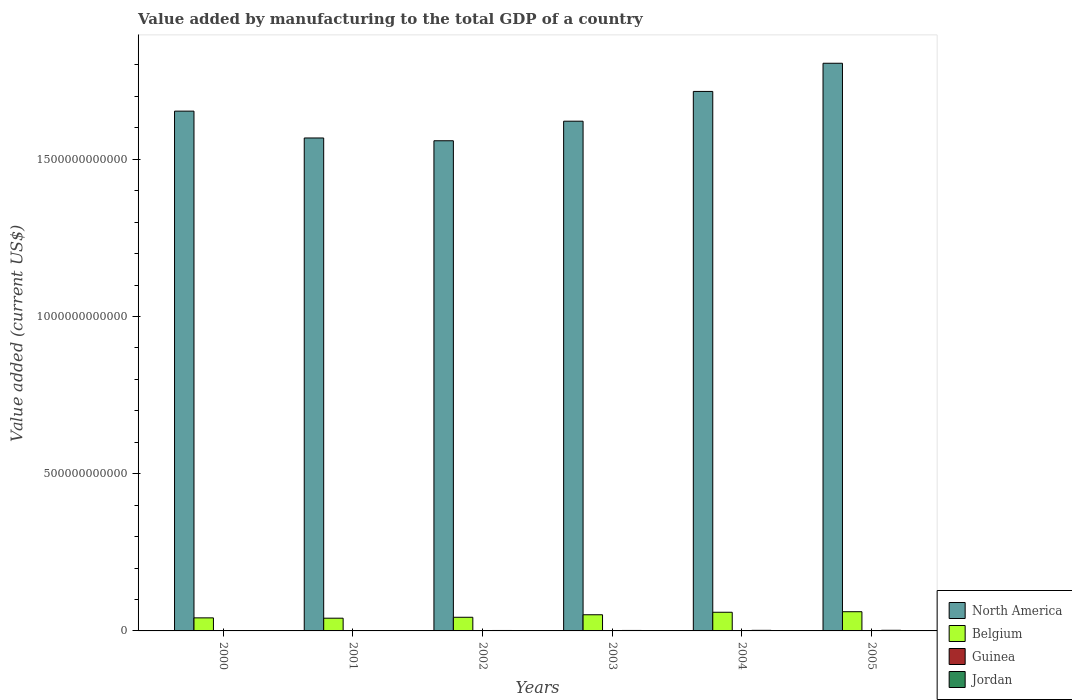How many different coloured bars are there?
Provide a short and direct response. 4. Are the number of bars on each tick of the X-axis equal?
Offer a terse response. Yes. How many bars are there on the 1st tick from the left?
Your response must be concise. 4. How many bars are there on the 2nd tick from the right?
Your answer should be compact. 4. What is the value added by manufacturing to the total GDP in Belgium in 2004?
Offer a terse response. 5.93e+1. Across all years, what is the maximum value added by manufacturing to the total GDP in Jordan?
Your answer should be compact. 2.01e+09. Across all years, what is the minimum value added by manufacturing to the total GDP in North America?
Provide a succinct answer. 1.56e+12. In which year was the value added by manufacturing to the total GDP in Guinea minimum?
Make the answer very short. 2001. What is the total value added by manufacturing to the total GDP in Belgium in the graph?
Make the answer very short. 2.97e+11. What is the difference between the value added by manufacturing to the total GDP in Jordan in 2001 and that in 2005?
Ensure brevity in your answer.  -7.97e+08. What is the difference between the value added by manufacturing to the total GDP in Jordan in 2000 and the value added by manufacturing to the total GDP in North America in 2003?
Offer a terse response. -1.62e+12. What is the average value added by manufacturing to the total GDP in Belgium per year?
Keep it short and to the point. 4.95e+1. In the year 2000, what is the difference between the value added by manufacturing to the total GDP in Belgium and value added by manufacturing to the total GDP in Guinea?
Your answer should be very brief. 4.14e+1. In how many years, is the value added by manufacturing to the total GDP in Belgium greater than 1200000000000 US$?
Provide a short and direct response. 0. What is the ratio of the value added by manufacturing to the total GDP in North America in 2002 to that in 2003?
Offer a very short reply. 0.96. Is the value added by manufacturing to the total GDP in North America in 2003 less than that in 2005?
Your answer should be very brief. Yes. What is the difference between the highest and the second highest value added by manufacturing to the total GDP in Guinea?
Ensure brevity in your answer.  3.41e+06. What is the difference between the highest and the lowest value added by manufacturing to the total GDP in Belgium?
Your answer should be very brief. 2.06e+1. What does the 2nd bar from the left in 2003 represents?
Offer a very short reply. Belgium. Are all the bars in the graph horizontal?
Make the answer very short. No. How many years are there in the graph?
Offer a very short reply. 6. What is the difference between two consecutive major ticks on the Y-axis?
Offer a terse response. 5.00e+11. Does the graph contain any zero values?
Keep it short and to the point. No. How many legend labels are there?
Offer a terse response. 4. How are the legend labels stacked?
Make the answer very short. Vertical. What is the title of the graph?
Give a very brief answer. Value added by manufacturing to the total GDP of a country. What is the label or title of the Y-axis?
Ensure brevity in your answer.  Value added (current US$). What is the Value added (current US$) of North America in 2000?
Give a very brief answer. 1.65e+12. What is the Value added (current US$) of Belgium in 2000?
Your answer should be compact. 4.15e+1. What is the Value added (current US$) in Guinea in 2000?
Ensure brevity in your answer.  1.13e+08. What is the Value added (current US$) of Jordan in 2000?
Your answer should be compact. 1.14e+09. What is the Value added (current US$) in North America in 2001?
Ensure brevity in your answer.  1.57e+12. What is the Value added (current US$) in Belgium in 2001?
Provide a short and direct response. 4.05e+1. What is the Value added (current US$) of Guinea in 2001?
Make the answer very short. 1.07e+08. What is the Value added (current US$) of Jordan in 2001?
Offer a very short reply. 1.21e+09. What is the Value added (current US$) of North America in 2002?
Offer a terse response. 1.56e+12. What is the Value added (current US$) of Belgium in 2002?
Your answer should be compact. 4.34e+1. What is the Value added (current US$) in Guinea in 2002?
Provide a short and direct response. 1.12e+08. What is the Value added (current US$) of Jordan in 2002?
Your response must be concise. 1.39e+09. What is the Value added (current US$) in North America in 2003?
Give a very brief answer. 1.62e+12. What is the Value added (current US$) of Belgium in 2003?
Your answer should be compact. 5.14e+1. What is the Value added (current US$) in Guinea in 2003?
Offer a very short reply. 2.04e+08. What is the Value added (current US$) in Jordan in 2003?
Keep it short and to the point. 1.53e+09. What is the Value added (current US$) of North America in 2004?
Your response must be concise. 1.72e+12. What is the Value added (current US$) in Belgium in 2004?
Provide a short and direct response. 5.93e+1. What is the Value added (current US$) of Guinea in 2004?
Make the answer very short. 2.08e+08. What is the Value added (current US$) in Jordan in 2004?
Ensure brevity in your answer.  1.85e+09. What is the Value added (current US$) in North America in 2005?
Provide a short and direct response. 1.81e+12. What is the Value added (current US$) of Belgium in 2005?
Provide a succinct answer. 6.11e+1. What is the Value added (current US$) in Guinea in 2005?
Offer a very short reply. 1.79e+08. What is the Value added (current US$) in Jordan in 2005?
Offer a very short reply. 2.01e+09. Across all years, what is the maximum Value added (current US$) of North America?
Your answer should be compact. 1.81e+12. Across all years, what is the maximum Value added (current US$) in Belgium?
Give a very brief answer. 6.11e+1. Across all years, what is the maximum Value added (current US$) in Guinea?
Your response must be concise. 2.08e+08. Across all years, what is the maximum Value added (current US$) in Jordan?
Provide a succinct answer. 2.01e+09. Across all years, what is the minimum Value added (current US$) of North America?
Your answer should be very brief. 1.56e+12. Across all years, what is the minimum Value added (current US$) in Belgium?
Your answer should be very brief. 4.05e+1. Across all years, what is the minimum Value added (current US$) in Guinea?
Your response must be concise. 1.07e+08. Across all years, what is the minimum Value added (current US$) in Jordan?
Give a very brief answer. 1.14e+09. What is the total Value added (current US$) of North America in the graph?
Offer a very short reply. 9.92e+12. What is the total Value added (current US$) of Belgium in the graph?
Your answer should be very brief. 2.97e+11. What is the total Value added (current US$) in Guinea in the graph?
Give a very brief answer. 9.22e+08. What is the total Value added (current US$) of Jordan in the graph?
Your answer should be compact. 9.14e+09. What is the difference between the Value added (current US$) of North America in 2000 and that in 2001?
Give a very brief answer. 8.53e+1. What is the difference between the Value added (current US$) of Belgium in 2000 and that in 2001?
Make the answer very short. 1.05e+09. What is the difference between the Value added (current US$) of Guinea in 2000 and that in 2001?
Your answer should be compact. 6.09e+06. What is the difference between the Value added (current US$) in Jordan in 2000 and that in 2001?
Your response must be concise. -7.61e+07. What is the difference between the Value added (current US$) in North America in 2000 and that in 2002?
Your response must be concise. 9.42e+1. What is the difference between the Value added (current US$) of Belgium in 2000 and that in 2002?
Ensure brevity in your answer.  -1.89e+09. What is the difference between the Value added (current US$) of Guinea in 2000 and that in 2002?
Ensure brevity in your answer.  1.40e+06. What is the difference between the Value added (current US$) in Jordan in 2000 and that in 2002?
Offer a very short reply. -2.54e+08. What is the difference between the Value added (current US$) in North America in 2000 and that in 2003?
Provide a succinct answer. 3.20e+1. What is the difference between the Value added (current US$) in Belgium in 2000 and that in 2003?
Keep it short and to the point. -9.85e+09. What is the difference between the Value added (current US$) of Guinea in 2000 and that in 2003?
Offer a terse response. -9.12e+07. What is the difference between the Value added (current US$) of Jordan in 2000 and that in 2003?
Make the answer very short. -3.88e+08. What is the difference between the Value added (current US$) of North America in 2000 and that in 2004?
Offer a terse response. -6.27e+1. What is the difference between the Value added (current US$) in Belgium in 2000 and that in 2004?
Your answer should be very brief. -1.78e+1. What is the difference between the Value added (current US$) of Guinea in 2000 and that in 2004?
Provide a short and direct response. -9.46e+07. What is the difference between the Value added (current US$) in Jordan in 2000 and that in 2004?
Make the answer very short. -7.14e+08. What is the difference between the Value added (current US$) in North America in 2000 and that in 2005?
Give a very brief answer. -1.52e+11. What is the difference between the Value added (current US$) of Belgium in 2000 and that in 2005?
Your answer should be very brief. -1.96e+1. What is the difference between the Value added (current US$) in Guinea in 2000 and that in 2005?
Your response must be concise. -6.56e+07. What is the difference between the Value added (current US$) in Jordan in 2000 and that in 2005?
Make the answer very short. -8.73e+08. What is the difference between the Value added (current US$) in North America in 2001 and that in 2002?
Give a very brief answer. 8.85e+09. What is the difference between the Value added (current US$) of Belgium in 2001 and that in 2002?
Offer a terse response. -2.94e+09. What is the difference between the Value added (current US$) of Guinea in 2001 and that in 2002?
Offer a terse response. -4.68e+06. What is the difference between the Value added (current US$) in Jordan in 2001 and that in 2002?
Provide a succinct answer. -1.78e+08. What is the difference between the Value added (current US$) of North America in 2001 and that in 2003?
Your answer should be compact. -5.34e+1. What is the difference between the Value added (current US$) of Belgium in 2001 and that in 2003?
Offer a very short reply. -1.09e+1. What is the difference between the Value added (current US$) of Guinea in 2001 and that in 2003?
Give a very brief answer. -9.73e+07. What is the difference between the Value added (current US$) of Jordan in 2001 and that in 2003?
Give a very brief answer. -3.12e+08. What is the difference between the Value added (current US$) in North America in 2001 and that in 2004?
Give a very brief answer. -1.48e+11. What is the difference between the Value added (current US$) in Belgium in 2001 and that in 2004?
Offer a very short reply. -1.88e+1. What is the difference between the Value added (current US$) of Guinea in 2001 and that in 2004?
Your answer should be very brief. -1.01e+08. What is the difference between the Value added (current US$) in Jordan in 2001 and that in 2004?
Your answer should be very brief. -6.38e+08. What is the difference between the Value added (current US$) in North America in 2001 and that in 2005?
Provide a succinct answer. -2.38e+11. What is the difference between the Value added (current US$) in Belgium in 2001 and that in 2005?
Provide a short and direct response. -2.06e+1. What is the difference between the Value added (current US$) in Guinea in 2001 and that in 2005?
Your answer should be compact. -7.17e+07. What is the difference between the Value added (current US$) in Jordan in 2001 and that in 2005?
Make the answer very short. -7.97e+08. What is the difference between the Value added (current US$) of North America in 2002 and that in 2003?
Provide a succinct answer. -6.22e+1. What is the difference between the Value added (current US$) of Belgium in 2002 and that in 2003?
Give a very brief answer. -7.96e+09. What is the difference between the Value added (current US$) of Guinea in 2002 and that in 2003?
Offer a very short reply. -9.26e+07. What is the difference between the Value added (current US$) of Jordan in 2002 and that in 2003?
Your response must be concise. -1.34e+08. What is the difference between the Value added (current US$) of North America in 2002 and that in 2004?
Offer a very short reply. -1.57e+11. What is the difference between the Value added (current US$) in Belgium in 2002 and that in 2004?
Keep it short and to the point. -1.59e+1. What is the difference between the Value added (current US$) in Guinea in 2002 and that in 2004?
Make the answer very short. -9.60e+07. What is the difference between the Value added (current US$) of Jordan in 2002 and that in 2004?
Offer a very short reply. -4.60e+08. What is the difference between the Value added (current US$) in North America in 2002 and that in 2005?
Provide a succinct answer. -2.46e+11. What is the difference between the Value added (current US$) in Belgium in 2002 and that in 2005?
Offer a very short reply. -1.77e+1. What is the difference between the Value added (current US$) of Guinea in 2002 and that in 2005?
Your answer should be very brief. -6.70e+07. What is the difference between the Value added (current US$) of Jordan in 2002 and that in 2005?
Your response must be concise. -6.19e+08. What is the difference between the Value added (current US$) of North America in 2003 and that in 2004?
Your answer should be compact. -9.47e+1. What is the difference between the Value added (current US$) in Belgium in 2003 and that in 2004?
Your answer should be very brief. -7.95e+09. What is the difference between the Value added (current US$) in Guinea in 2003 and that in 2004?
Your answer should be very brief. -3.41e+06. What is the difference between the Value added (current US$) of Jordan in 2003 and that in 2004?
Provide a short and direct response. -3.26e+08. What is the difference between the Value added (current US$) in North America in 2003 and that in 2005?
Your response must be concise. -1.84e+11. What is the difference between the Value added (current US$) in Belgium in 2003 and that in 2005?
Your response must be concise. -9.71e+09. What is the difference between the Value added (current US$) of Guinea in 2003 and that in 2005?
Your response must be concise. 2.56e+07. What is the difference between the Value added (current US$) in Jordan in 2003 and that in 2005?
Keep it short and to the point. -4.85e+08. What is the difference between the Value added (current US$) in North America in 2004 and that in 2005?
Provide a short and direct response. -8.96e+1. What is the difference between the Value added (current US$) of Belgium in 2004 and that in 2005?
Your answer should be very brief. -1.77e+09. What is the difference between the Value added (current US$) of Guinea in 2004 and that in 2005?
Your response must be concise. 2.90e+07. What is the difference between the Value added (current US$) of Jordan in 2004 and that in 2005?
Your response must be concise. -1.59e+08. What is the difference between the Value added (current US$) of North America in 2000 and the Value added (current US$) of Belgium in 2001?
Offer a terse response. 1.61e+12. What is the difference between the Value added (current US$) in North America in 2000 and the Value added (current US$) in Guinea in 2001?
Ensure brevity in your answer.  1.65e+12. What is the difference between the Value added (current US$) of North America in 2000 and the Value added (current US$) of Jordan in 2001?
Your response must be concise. 1.65e+12. What is the difference between the Value added (current US$) in Belgium in 2000 and the Value added (current US$) in Guinea in 2001?
Ensure brevity in your answer.  4.14e+1. What is the difference between the Value added (current US$) of Belgium in 2000 and the Value added (current US$) of Jordan in 2001?
Keep it short and to the point. 4.03e+1. What is the difference between the Value added (current US$) of Guinea in 2000 and the Value added (current US$) of Jordan in 2001?
Your answer should be compact. -1.10e+09. What is the difference between the Value added (current US$) in North America in 2000 and the Value added (current US$) in Belgium in 2002?
Provide a succinct answer. 1.61e+12. What is the difference between the Value added (current US$) of North America in 2000 and the Value added (current US$) of Guinea in 2002?
Give a very brief answer. 1.65e+12. What is the difference between the Value added (current US$) in North America in 2000 and the Value added (current US$) in Jordan in 2002?
Provide a succinct answer. 1.65e+12. What is the difference between the Value added (current US$) of Belgium in 2000 and the Value added (current US$) of Guinea in 2002?
Your answer should be very brief. 4.14e+1. What is the difference between the Value added (current US$) of Belgium in 2000 and the Value added (current US$) of Jordan in 2002?
Give a very brief answer. 4.01e+1. What is the difference between the Value added (current US$) of Guinea in 2000 and the Value added (current US$) of Jordan in 2002?
Make the answer very short. -1.28e+09. What is the difference between the Value added (current US$) of North America in 2000 and the Value added (current US$) of Belgium in 2003?
Provide a short and direct response. 1.60e+12. What is the difference between the Value added (current US$) of North America in 2000 and the Value added (current US$) of Guinea in 2003?
Provide a short and direct response. 1.65e+12. What is the difference between the Value added (current US$) of North America in 2000 and the Value added (current US$) of Jordan in 2003?
Offer a terse response. 1.65e+12. What is the difference between the Value added (current US$) in Belgium in 2000 and the Value added (current US$) in Guinea in 2003?
Provide a short and direct response. 4.13e+1. What is the difference between the Value added (current US$) in Belgium in 2000 and the Value added (current US$) in Jordan in 2003?
Provide a succinct answer. 4.00e+1. What is the difference between the Value added (current US$) of Guinea in 2000 and the Value added (current US$) of Jordan in 2003?
Offer a terse response. -1.41e+09. What is the difference between the Value added (current US$) in North America in 2000 and the Value added (current US$) in Belgium in 2004?
Your response must be concise. 1.59e+12. What is the difference between the Value added (current US$) of North America in 2000 and the Value added (current US$) of Guinea in 2004?
Offer a very short reply. 1.65e+12. What is the difference between the Value added (current US$) in North America in 2000 and the Value added (current US$) in Jordan in 2004?
Make the answer very short. 1.65e+12. What is the difference between the Value added (current US$) of Belgium in 2000 and the Value added (current US$) of Guinea in 2004?
Offer a very short reply. 4.13e+1. What is the difference between the Value added (current US$) in Belgium in 2000 and the Value added (current US$) in Jordan in 2004?
Give a very brief answer. 3.97e+1. What is the difference between the Value added (current US$) in Guinea in 2000 and the Value added (current US$) in Jordan in 2004?
Your answer should be compact. -1.74e+09. What is the difference between the Value added (current US$) of North America in 2000 and the Value added (current US$) of Belgium in 2005?
Keep it short and to the point. 1.59e+12. What is the difference between the Value added (current US$) in North America in 2000 and the Value added (current US$) in Guinea in 2005?
Keep it short and to the point. 1.65e+12. What is the difference between the Value added (current US$) in North America in 2000 and the Value added (current US$) in Jordan in 2005?
Your answer should be compact. 1.65e+12. What is the difference between the Value added (current US$) in Belgium in 2000 and the Value added (current US$) in Guinea in 2005?
Your answer should be very brief. 4.14e+1. What is the difference between the Value added (current US$) of Belgium in 2000 and the Value added (current US$) of Jordan in 2005?
Keep it short and to the point. 3.95e+1. What is the difference between the Value added (current US$) in Guinea in 2000 and the Value added (current US$) in Jordan in 2005?
Offer a very short reply. -1.90e+09. What is the difference between the Value added (current US$) of North America in 2001 and the Value added (current US$) of Belgium in 2002?
Your response must be concise. 1.52e+12. What is the difference between the Value added (current US$) of North America in 2001 and the Value added (current US$) of Guinea in 2002?
Offer a terse response. 1.57e+12. What is the difference between the Value added (current US$) in North America in 2001 and the Value added (current US$) in Jordan in 2002?
Your answer should be very brief. 1.57e+12. What is the difference between the Value added (current US$) of Belgium in 2001 and the Value added (current US$) of Guinea in 2002?
Make the answer very short. 4.04e+1. What is the difference between the Value added (current US$) in Belgium in 2001 and the Value added (current US$) in Jordan in 2002?
Make the answer very short. 3.91e+1. What is the difference between the Value added (current US$) of Guinea in 2001 and the Value added (current US$) of Jordan in 2002?
Keep it short and to the point. -1.29e+09. What is the difference between the Value added (current US$) in North America in 2001 and the Value added (current US$) in Belgium in 2003?
Make the answer very short. 1.52e+12. What is the difference between the Value added (current US$) in North America in 2001 and the Value added (current US$) in Guinea in 2003?
Your response must be concise. 1.57e+12. What is the difference between the Value added (current US$) in North America in 2001 and the Value added (current US$) in Jordan in 2003?
Provide a short and direct response. 1.57e+12. What is the difference between the Value added (current US$) of Belgium in 2001 and the Value added (current US$) of Guinea in 2003?
Make the answer very short. 4.03e+1. What is the difference between the Value added (current US$) of Belgium in 2001 and the Value added (current US$) of Jordan in 2003?
Provide a succinct answer. 3.90e+1. What is the difference between the Value added (current US$) of Guinea in 2001 and the Value added (current US$) of Jordan in 2003?
Give a very brief answer. -1.42e+09. What is the difference between the Value added (current US$) in North America in 2001 and the Value added (current US$) in Belgium in 2004?
Ensure brevity in your answer.  1.51e+12. What is the difference between the Value added (current US$) in North America in 2001 and the Value added (current US$) in Guinea in 2004?
Your answer should be compact. 1.57e+12. What is the difference between the Value added (current US$) in North America in 2001 and the Value added (current US$) in Jordan in 2004?
Your answer should be very brief. 1.57e+12. What is the difference between the Value added (current US$) in Belgium in 2001 and the Value added (current US$) in Guinea in 2004?
Your response must be concise. 4.03e+1. What is the difference between the Value added (current US$) of Belgium in 2001 and the Value added (current US$) of Jordan in 2004?
Provide a short and direct response. 3.86e+1. What is the difference between the Value added (current US$) of Guinea in 2001 and the Value added (current US$) of Jordan in 2004?
Your answer should be very brief. -1.75e+09. What is the difference between the Value added (current US$) in North America in 2001 and the Value added (current US$) in Belgium in 2005?
Your answer should be very brief. 1.51e+12. What is the difference between the Value added (current US$) in North America in 2001 and the Value added (current US$) in Guinea in 2005?
Provide a succinct answer. 1.57e+12. What is the difference between the Value added (current US$) in North America in 2001 and the Value added (current US$) in Jordan in 2005?
Make the answer very short. 1.57e+12. What is the difference between the Value added (current US$) of Belgium in 2001 and the Value added (current US$) of Guinea in 2005?
Give a very brief answer. 4.03e+1. What is the difference between the Value added (current US$) of Belgium in 2001 and the Value added (current US$) of Jordan in 2005?
Make the answer very short. 3.85e+1. What is the difference between the Value added (current US$) of Guinea in 2001 and the Value added (current US$) of Jordan in 2005?
Provide a succinct answer. -1.90e+09. What is the difference between the Value added (current US$) in North America in 2002 and the Value added (current US$) in Belgium in 2003?
Offer a very short reply. 1.51e+12. What is the difference between the Value added (current US$) in North America in 2002 and the Value added (current US$) in Guinea in 2003?
Your answer should be very brief. 1.56e+12. What is the difference between the Value added (current US$) of North America in 2002 and the Value added (current US$) of Jordan in 2003?
Offer a terse response. 1.56e+12. What is the difference between the Value added (current US$) in Belgium in 2002 and the Value added (current US$) in Guinea in 2003?
Offer a very short reply. 4.32e+1. What is the difference between the Value added (current US$) of Belgium in 2002 and the Value added (current US$) of Jordan in 2003?
Ensure brevity in your answer.  4.19e+1. What is the difference between the Value added (current US$) of Guinea in 2002 and the Value added (current US$) of Jordan in 2003?
Your response must be concise. -1.42e+09. What is the difference between the Value added (current US$) in North America in 2002 and the Value added (current US$) in Belgium in 2004?
Keep it short and to the point. 1.50e+12. What is the difference between the Value added (current US$) of North America in 2002 and the Value added (current US$) of Guinea in 2004?
Give a very brief answer. 1.56e+12. What is the difference between the Value added (current US$) of North America in 2002 and the Value added (current US$) of Jordan in 2004?
Provide a succinct answer. 1.56e+12. What is the difference between the Value added (current US$) in Belgium in 2002 and the Value added (current US$) in Guinea in 2004?
Provide a short and direct response. 4.32e+1. What is the difference between the Value added (current US$) in Belgium in 2002 and the Value added (current US$) in Jordan in 2004?
Make the answer very short. 4.16e+1. What is the difference between the Value added (current US$) of Guinea in 2002 and the Value added (current US$) of Jordan in 2004?
Provide a short and direct response. -1.74e+09. What is the difference between the Value added (current US$) of North America in 2002 and the Value added (current US$) of Belgium in 2005?
Your answer should be very brief. 1.50e+12. What is the difference between the Value added (current US$) in North America in 2002 and the Value added (current US$) in Guinea in 2005?
Your answer should be compact. 1.56e+12. What is the difference between the Value added (current US$) in North America in 2002 and the Value added (current US$) in Jordan in 2005?
Ensure brevity in your answer.  1.56e+12. What is the difference between the Value added (current US$) of Belgium in 2002 and the Value added (current US$) of Guinea in 2005?
Offer a very short reply. 4.32e+1. What is the difference between the Value added (current US$) of Belgium in 2002 and the Value added (current US$) of Jordan in 2005?
Offer a terse response. 4.14e+1. What is the difference between the Value added (current US$) in Guinea in 2002 and the Value added (current US$) in Jordan in 2005?
Offer a terse response. -1.90e+09. What is the difference between the Value added (current US$) in North America in 2003 and the Value added (current US$) in Belgium in 2004?
Offer a terse response. 1.56e+12. What is the difference between the Value added (current US$) of North America in 2003 and the Value added (current US$) of Guinea in 2004?
Your answer should be very brief. 1.62e+12. What is the difference between the Value added (current US$) of North America in 2003 and the Value added (current US$) of Jordan in 2004?
Your answer should be compact. 1.62e+12. What is the difference between the Value added (current US$) of Belgium in 2003 and the Value added (current US$) of Guinea in 2004?
Your answer should be very brief. 5.12e+1. What is the difference between the Value added (current US$) in Belgium in 2003 and the Value added (current US$) in Jordan in 2004?
Give a very brief answer. 4.95e+1. What is the difference between the Value added (current US$) in Guinea in 2003 and the Value added (current US$) in Jordan in 2004?
Your response must be concise. -1.65e+09. What is the difference between the Value added (current US$) of North America in 2003 and the Value added (current US$) of Belgium in 2005?
Offer a very short reply. 1.56e+12. What is the difference between the Value added (current US$) in North America in 2003 and the Value added (current US$) in Guinea in 2005?
Make the answer very short. 1.62e+12. What is the difference between the Value added (current US$) in North America in 2003 and the Value added (current US$) in Jordan in 2005?
Your answer should be very brief. 1.62e+12. What is the difference between the Value added (current US$) in Belgium in 2003 and the Value added (current US$) in Guinea in 2005?
Provide a succinct answer. 5.12e+1. What is the difference between the Value added (current US$) in Belgium in 2003 and the Value added (current US$) in Jordan in 2005?
Ensure brevity in your answer.  4.94e+1. What is the difference between the Value added (current US$) in Guinea in 2003 and the Value added (current US$) in Jordan in 2005?
Provide a succinct answer. -1.81e+09. What is the difference between the Value added (current US$) in North America in 2004 and the Value added (current US$) in Belgium in 2005?
Offer a terse response. 1.65e+12. What is the difference between the Value added (current US$) of North America in 2004 and the Value added (current US$) of Guinea in 2005?
Your answer should be very brief. 1.72e+12. What is the difference between the Value added (current US$) in North America in 2004 and the Value added (current US$) in Jordan in 2005?
Ensure brevity in your answer.  1.71e+12. What is the difference between the Value added (current US$) in Belgium in 2004 and the Value added (current US$) in Guinea in 2005?
Your response must be concise. 5.92e+1. What is the difference between the Value added (current US$) in Belgium in 2004 and the Value added (current US$) in Jordan in 2005?
Give a very brief answer. 5.73e+1. What is the difference between the Value added (current US$) in Guinea in 2004 and the Value added (current US$) in Jordan in 2005?
Provide a short and direct response. -1.80e+09. What is the average Value added (current US$) in North America per year?
Provide a succinct answer. 1.65e+12. What is the average Value added (current US$) of Belgium per year?
Give a very brief answer. 4.95e+1. What is the average Value added (current US$) in Guinea per year?
Ensure brevity in your answer.  1.54e+08. What is the average Value added (current US$) of Jordan per year?
Provide a succinct answer. 1.52e+09. In the year 2000, what is the difference between the Value added (current US$) in North America and Value added (current US$) in Belgium?
Offer a terse response. 1.61e+12. In the year 2000, what is the difference between the Value added (current US$) of North America and Value added (current US$) of Guinea?
Your response must be concise. 1.65e+12. In the year 2000, what is the difference between the Value added (current US$) of North America and Value added (current US$) of Jordan?
Your answer should be compact. 1.65e+12. In the year 2000, what is the difference between the Value added (current US$) in Belgium and Value added (current US$) in Guinea?
Keep it short and to the point. 4.14e+1. In the year 2000, what is the difference between the Value added (current US$) in Belgium and Value added (current US$) in Jordan?
Your answer should be very brief. 4.04e+1. In the year 2000, what is the difference between the Value added (current US$) of Guinea and Value added (current US$) of Jordan?
Make the answer very short. -1.03e+09. In the year 2001, what is the difference between the Value added (current US$) in North America and Value added (current US$) in Belgium?
Your answer should be compact. 1.53e+12. In the year 2001, what is the difference between the Value added (current US$) in North America and Value added (current US$) in Guinea?
Ensure brevity in your answer.  1.57e+12. In the year 2001, what is the difference between the Value added (current US$) of North America and Value added (current US$) of Jordan?
Make the answer very short. 1.57e+12. In the year 2001, what is the difference between the Value added (current US$) of Belgium and Value added (current US$) of Guinea?
Provide a succinct answer. 4.04e+1. In the year 2001, what is the difference between the Value added (current US$) of Belgium and Value added (current US$) of Jordan?
Ensure brevity in your answer.  3.93e+1. In the year 2001, what is the difference between the Value added (current US$) of Guinea and Value added (current US$) of Jordan?
Offer a very short reply. -1.11e+09. In the year 2002, what is the difference between the Value added (current US$) of North America and Value added (current US$) of Belgium?
Provide a short and direct response. 1.52e+12. In the year 2002, what is the difference between the Value added (current US$) of North America and Value added (current US$) of Guinea?
Offer a very short reply. 1.56e+12. In the year 2002, what is the difference between the Value added (current US$) in North America and Value added (current US$) in Jordan?
Offer a terse response. 1.56e+12. In the year 2002, what is the difference between the Value added (current US$) of Belgium and Value added (current US$) of Guinea?
Your answer should be compact. 4.33e+1. In the year 2002, what is the difference between the Value added (current US$) in Belgium and Value added (current US$) in Jordan?
Ensure brevity in your answer.  4.20e+1. In the year 2002, what is the difference between the Value added (current US$) of Guinea and Value added (current US$) of Jordan?
Keep it short and to the point. -1.28e+09. In the year 2003, what is the difference between the Value added (current US$) of North America and Value added (current US$) of Belgium?
Give a very brief answer. 1.57e+12. In the year 2003, what is the difference between the Value added (current US$) of North America and Value added (current US$) of Guinea?
Your answer should be compact. 1.62e+12. In the year 2003, what is the difference between the Value added (current US$) in North America and Value added (current US$) in Jordan?
Ensure brevity in your answer.  1.62e+12. In the year 2003, what is the difference between the Value added (current US$) of Belgium and Value added (current US$) of Guinea?
Your response must be concise. 5.12e+1. In the year 2003, what is the difference between the Value added (current US$) in Belgium and Value added (current US$) in Jordan?
Give a very brief answer. 4.99e+1. In the year 2003, what is the difference between the Value added (current US$) in Guinea and Value added (current US$) in Jordan?
Your response must be concise. -1.32e+09. In the year 2004, what is the difference between the Value added (current US$) of North America and Value added (current US$) of Belgium?
Provide a short and direct response. 1.66e+12. In the year 2004, what is the difference between the Value added (current US$) in North America and Value added (current US$) in Guinea?
Keep it short and to the point. 1.72e+12. In the year 2004, what is the difference between the Value added (current US$) of North America and Value added (current US$) of Jordan?
Your answer should be very brief. 1.71e+12. In the year 2004, what is the difference between the Value added (current US$) of Belgium and Value added (current US$) of Guinea?
Your response must be concise. 5.91e+1. In the year 2004, what is the difference between the Value added (current US$) of Belgium and Value added (current US$) of Jordan?
Ensure brevity in your answer.  5.75e+1. In the year 2004, what is the difference between the Value added (current US$) of Guinea and Value added (current US$) of Jordan?
Offer a terse response. -1.65e+09. In the year 2005, what is the difference between the Value added (current US$) of North America and Value added (current US$) of Belgium?
Give a very brief answer. 1.74e+12. In the year 2005, what is the difference between the Value added (current US$) in North America and Value added (current US$) in Guinea?
Offer a terse response. 1.80e+12. In the year 2005, what is the difference between the Value added (current US$) of North America and Value added (current US$) of Jordan?
Your answer should be compact. 1.80e+12. In the year 2005, what is the difference between the Value added (current US$) of Belgium and Value added (current US$) of Guinea?
Provide a short and direct response. 6.09e+1. In the year 2005, what is the difference between the Value added (current US$) in Belgium and Value added (current US$) in Jordan?
Your answer should be very brief. 5.91e+1. In the year 2005, what is the difference between the Value added (current US$) in Guinea and Value added (current US$) in Jordan?
Keep it short and to the point. -1.83e+09. What is the ratio of the Value added (current US$) of North America in 2000 to that in 2001?
Your answer should be very brief. 1.05. What is the ratio of the Value added (current US$) in Belgium in 2000 to that in 2001?
Offer a terse response. 1.03. What is the ratio of the Value added (current US$) in Guinea in 2000 to that in 2001?
Make the answer very short. 1.06. What is the ratio of the Value added (current US$) in Jordan in 2000 to that in 2001?
Offer a very short reply. 0.94. What is the ratio of the Value added (current US$) of North America in 2000 to that in 2002?
Your answer should be compact. 1.06. What is the ratio of the Value added (current US$) of Belgium in 2000 to that in 2002?
Make the answer very short. 0.96. What is the ratio of the Value added (current US$) in Guinea in 2000 to that in 2002?
Your response must be concise. 1.01. What is the ratio of the Value added (current US$) in Jordan in 2000 to that in 2002?
Your response must be concise. 0.82. What is the ratio of the Value added (current US$) in North America in 2000 to that in 2003?
Keep it short and to the point. 1.02. What is the ratio of the Value added (current US$) of Belgium in 2000 to that in 2003?
Your answer should be compact. 0.81. What is the ratio of the Value added (current US$) of Guinea in 2000 to that in 2003?
Your answer should be very brief. 0.55. What is the ratio of the Value added (current US$) in Jordan in 2000 to that in 2003?
Make the answer very short. 0.75. What is the ratio of the Value added (current US$) of North America in 2000 to that in 2004?
Keep it short and to the point. 0.96. What is the ratio of the Value added (current US$) in Belgium in 2000 to that in 2004?
Provide a succinct answer. 0.7. What is the ratio of the Value added (current US$) of Guinea in 2000 to that in 2004?
Provide a short and direct response. 0.54. What is the ratio of the Value added (current US$) of Jordan in 2000 to that in 2004?
Provide a succinct answer. 0.61. What is the ratio of the Value added (current US$) of North America in 2000 to that in 2005?
Your answer should be very brief. 0.92. What is the ratio of the Value added (current US$) of Belgium in 2000 to that in 2005?
Keep it short and to the point. 0.68. What is the ratio of the Value added (current US$) in Guinea in 2000 to that in 2005?
Make the answer very short. 0.63. What is the ratio of the Value added (current US$) in Jordan in 2000 to that in 2005?
Keep it short and to the point. 0.57. What is the ratio of the Value added (current US$) in Belgium in 2001 to that in 2002?
Keep it short and to the point. 0.93. What is the ratio of the Value added (current US$) in Guinea in 2001 to that in 2002?
Keep it short and to the point. 0.96. What is the ratio of the Value added (current US$) in Jordan in 2001 to that in 2002?
Your answer should be compact. 0.87. What is the ratio of the Value added (current US$) of North America in 2001 to that in 2003?
Your response must be concise. 0.97. What is the ratio of the Value added (current US$) of Belgium in 2001 to that in 2003?
Ensure brevity in your answer.  0.79. What is the ratio of the Value added (current US$) of Guinea in 2001 to that in 2003?
Your answer should be compact. 0.52. What is the ratio of the Value added (current US$) of Jordan in 2001 to that in 2003?
Your answer should be compact. 0.8. What is the ratio of the Value added (current US$) in North America in 2001 to that in 2004?
Ensure brevity in your answer.  0.91. What is the ratio of the Value added (current US$) in Belgium in 2001 to that in 2004?
Offer a very short reply. 0.68. What is the ratio of the Value added (current US$) in Guinea in 2001 to that in 2004?
Your answer should be very brief. 0.52. What is the ratio of the Value added (current US$) in Jordan in 2001 to that in 2004?
Your answer should be very brief. 0.66. What is the ratio of the Value added (current US$) of North America in 2001 to that in 2005?
Give a very brief answer. 0.87. What is the ratio of the Value added (current US$) of Belgium in 2001 to that in 2005?
Your response must be concise. 0.66. What is the ratio of the Value added (current US$) in Guinea in 2001 to that in 2005?
Offer a very short reply. 0.6. What is the ratio of the Value added (current US$) of Jordan in 2001 to that in 2005?
Keep it short and to the point. 0.6. What is the ratio of the Value added (current US$) of North America in 2002 to that in 2003?
Keep it short and to the point. 0.96. What is the ratio of the Value added (current US$) in Belgium in 2002 to that in 2003?
Keep it short and to the point. 0.85. What is the ratio of the Value added (current US$) of Guinea in 2002 to that in 2003?
Provide a succinct answer. 0.55. What is the ratio of the Value added (current US$) in Jordan in 2002 to that in 2003?
Your response must be concise. 0.91. What is the ratio of the Value added (current US$) in North America in 2002 to that in 2004?
Provide a succinct answer. 0.91. What is the ratio of the Value added (current US$) in Belgium in 2002 to that in 2004?
Ensure brevity in your answer.  0.73. What is the ratio of the Value added (current US$) of Guinea in 2002 to that in 2004?
Offer a very short reply. 0.54. What is the ratio of the Value added (current US$) in Jordan in 2002 to that in 2004?
Your answer should be compact. 0.75. What is the ratio of the Value added (current US$) of North America in 2002 to that in 2005?
Your answer should be very brief. 0.86. What is the ratio of the Value added (current US$) of Belgium in 2002 to that in 2005?
Offer a very short reply. 0.71. What is the ratio of the Value added (current US$) in Guinea in 2002 to that in 2005?
Ensure brevity in your answer.  0.62. What is the ratio of the Value added (current US$) in Jordan in 2002 to that in 2005?
Provide a succinct answer. 0.69. What is the ratio of the Value added (current US$) in North America in 2003 to that in 2004?
Your response must be concise. 0.94. What is the ratio of the Value added (current US$) in Belgium in 2003 to that in 2004?
Your answer should be compact. 0.87. What is the ratio of the Value added (current US$) in Guinea in 2003 to that in 2004?
Give a very brief answer. 0.98. What is the ratio of the Value added (current US$) of Jordan in 2003 to that in 2004?
Your answer should be compact. 0.82. What is the ratio of the Value added (current US$) of North America in 2003 to that in 2005?
Your answer should be compact. 0.9. What is the ratio of the Value added (current US$) in Belgium in 2003 to that in 2005?
Make the answer very short. 0.84. What is the ratio of the Value added (current US$) in Guinea in 2003 to that in 2005?
Keep it short and to the point. 1.14. What is the ratio of the Value added (current US$) in Jordan in 2003 to that in 2005?
Provide a short and direct response. 0.76. What is the ratio of the Value added (current US$) in North America in 2004 to that in 2005?
Offer a terse response. 0.95. What is the ratio of the Value added (current US$) in Belgium in 2004 to that in 2005?
Your answer should be very brief. 0.97. What is the ratio of the Value added (current US$) of Guinea in 2004 to that in 2005?
Provide a short and direct response. 1.16. What is the ratio of the Value added (current US$) in Jordan in 2004 to that in 2005?
Provide a succinct answer. 0.92. What is the difference between the highest and the second highest Value added (current US$) in North America?
Offer a very short reply. 8.96e+1. What is the difference between the highest and the second highest Value added (current US$) of Belgium?
Your answer should be compact. 1.77e+09. What is the difference between the highest and the second highest Value added (current US$) of Guinea?
Provide a succinct answer. 3.41e+06. What is the difference between the highest and the second highest Value added (current US$) of Jordan?
Ensure brevity in your answer.  1.59e+08. What is the difference between the highest and the lowest Value added (current US$) in North America?
Provide a succinct answer. 2.46e+11. What is the difference between the highest and the lowest Value added (current US$) of Belgium?
Offer a very short reply. 2.06e+1. What is the difference between the highest and the lowest Value added (current US$) of Guinea?
Ensure brevity in your answer.  1.01e+08. What is the difference between the highest and the lowest Value added (current US$) of Jordan?
Offer a very short reply. 8.73e+08. 